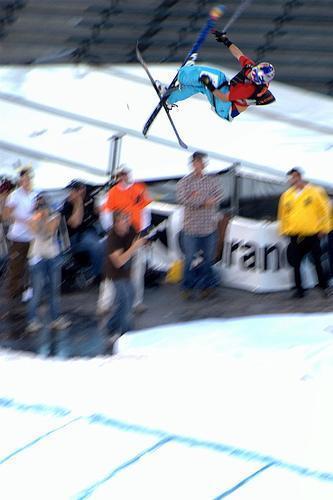How many skiers are there?
Give a very brief answer. 1. 